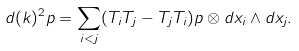<formula> <loc_0><loc_0><loc_500><loc_500>d ( k ) ^ { 2 } p = \sum _ { i < j } ( T _ { i } T _ { j } - T _ { j } T _ { i } ) p \otimes d x _ { i } \wedge d x _ { j } .</formula> 